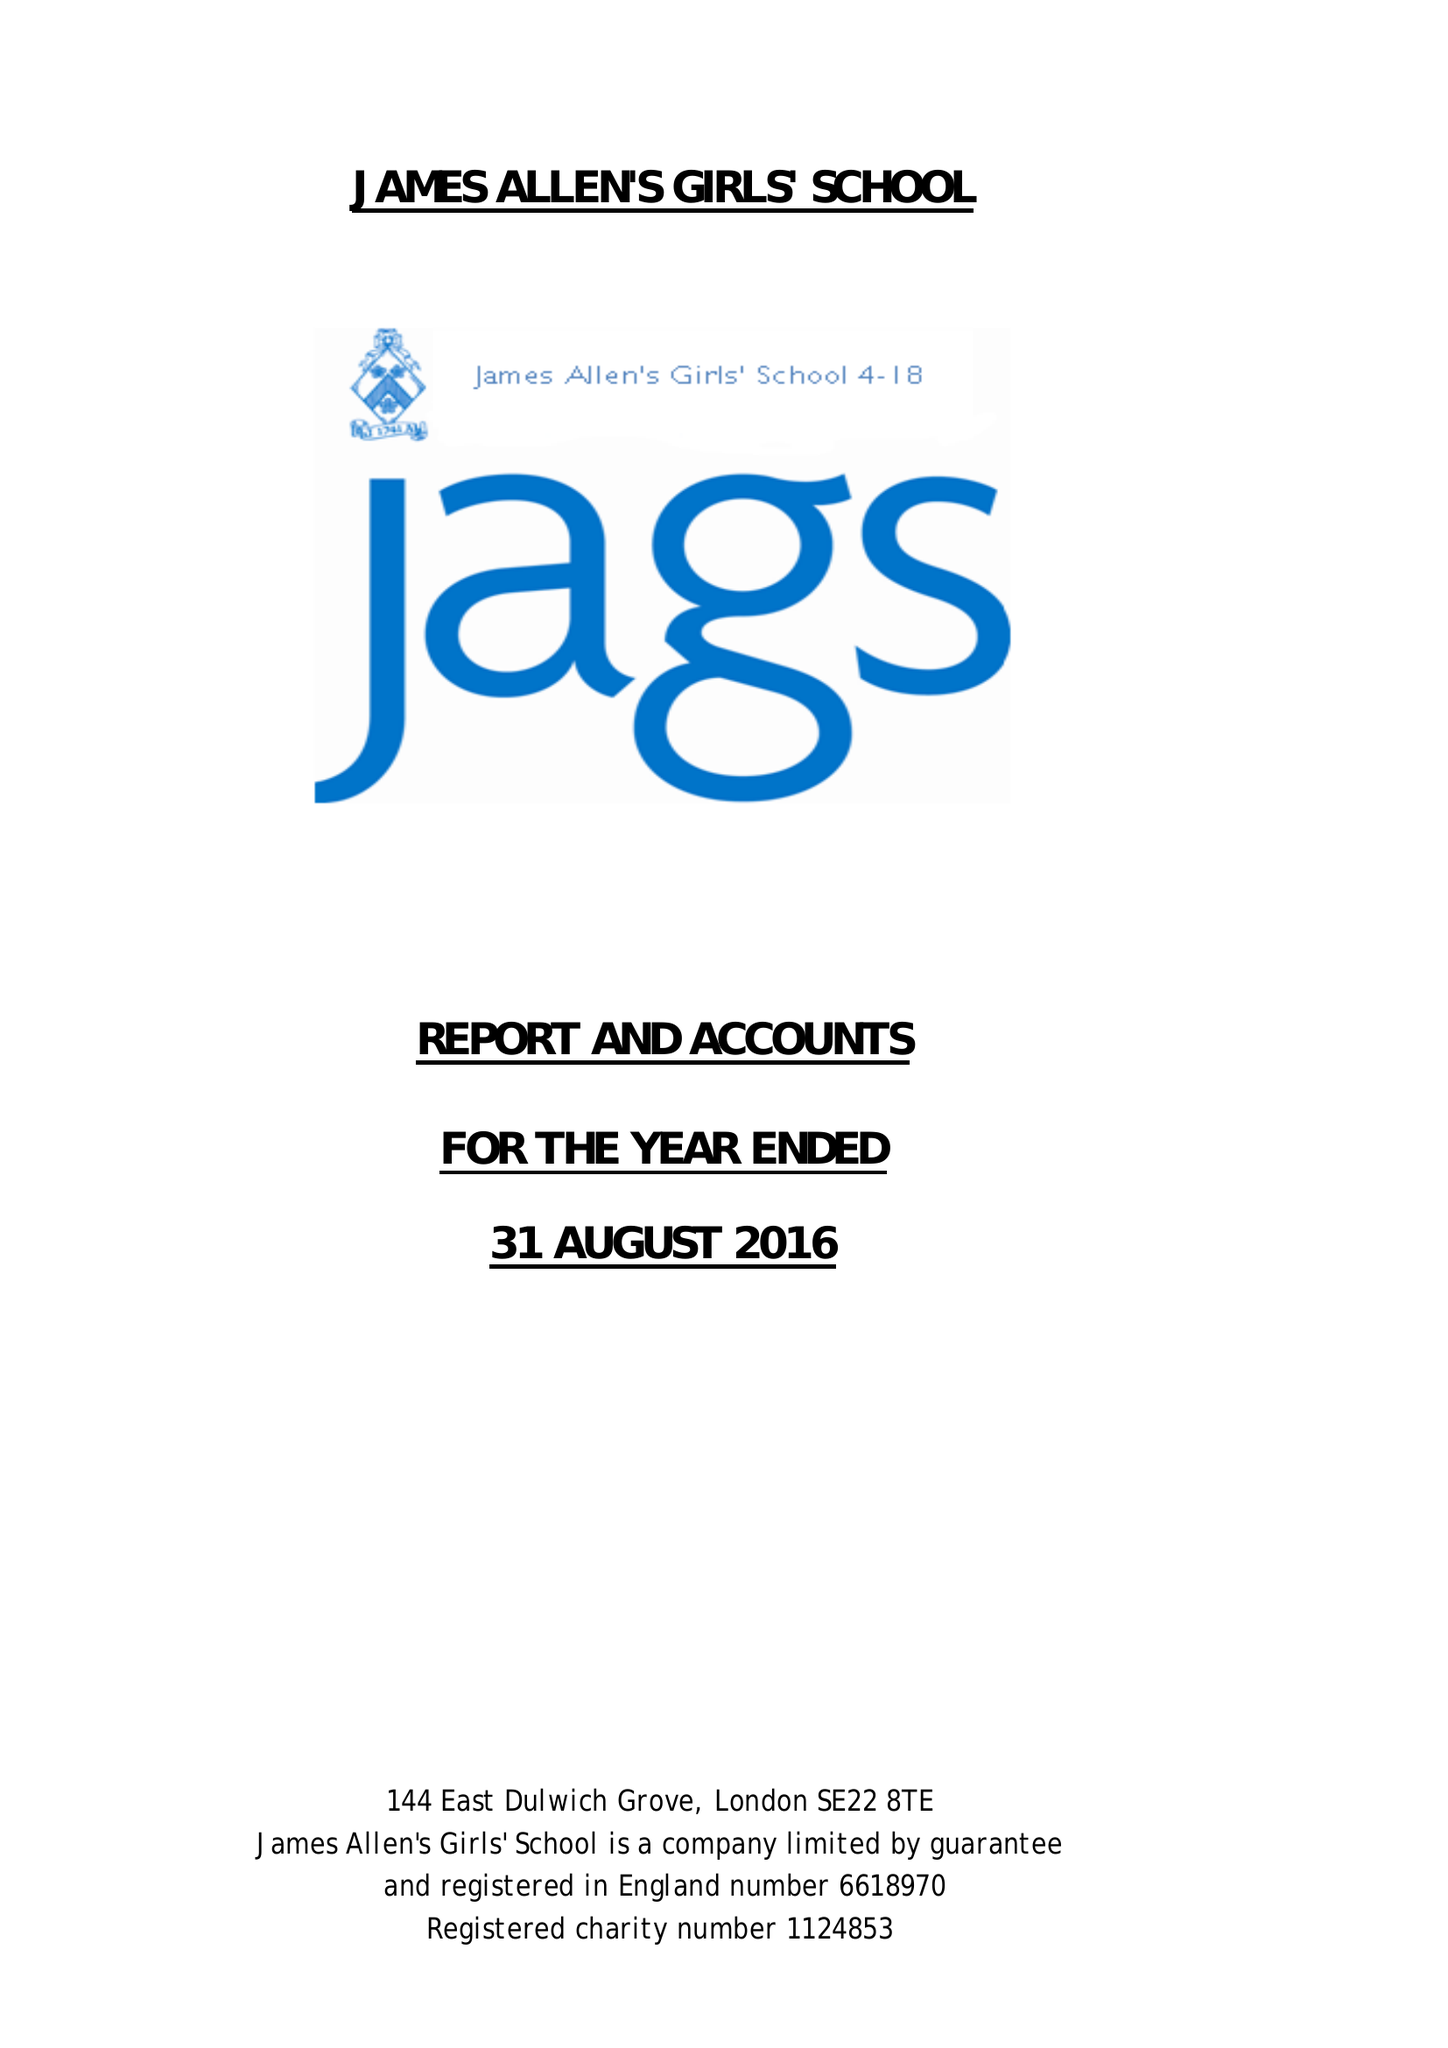What is the value for the address__post_town?
Answer the question using a single word or phrase. LONDON 